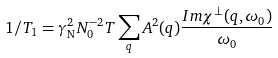<formula> <loc_0><loc_0><loc_500><loc_500>1 / T _ { 1 } = \gamma _ { \text {N} } ^ { 2 } N _ { 0 } ^ { - 2 } T \sum _ { q } A ^ { 2 } ( q ) \frac { I m \chi ^ { \bot } ( q , \omega _ { 0 } ) } { \omega _ { 0 } }</formula> 